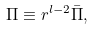<formula> <loc_0><loc_0><loc_500><loc_500>\Pi \equiv r ^ { l - 2 } \bar { \Pi } ,</formula> 